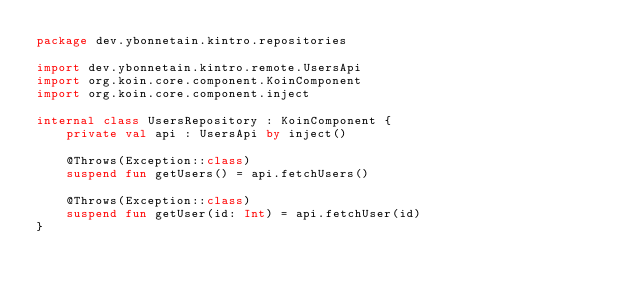<code> <loc_0><loc_0><loc_500><loc_500><_Kotlin_>package dev.ybonnetain.kintro.repositories

import dev.ybonnetain.kintro.remote.UsersApi
import org.koin.core.component.KoinComponent
import org.koin.core.component.inject

internal class UsersRepository : KoinComponent {
    private val api : UsersApi by inject()

    @Throws(Exception::class)
    suspend fun getUsers() = api.fetchUsers()

    @Throws(Exception::class)
    suspend fun getUser(id: Int) = api.fetchUser(id)
}
</code> 